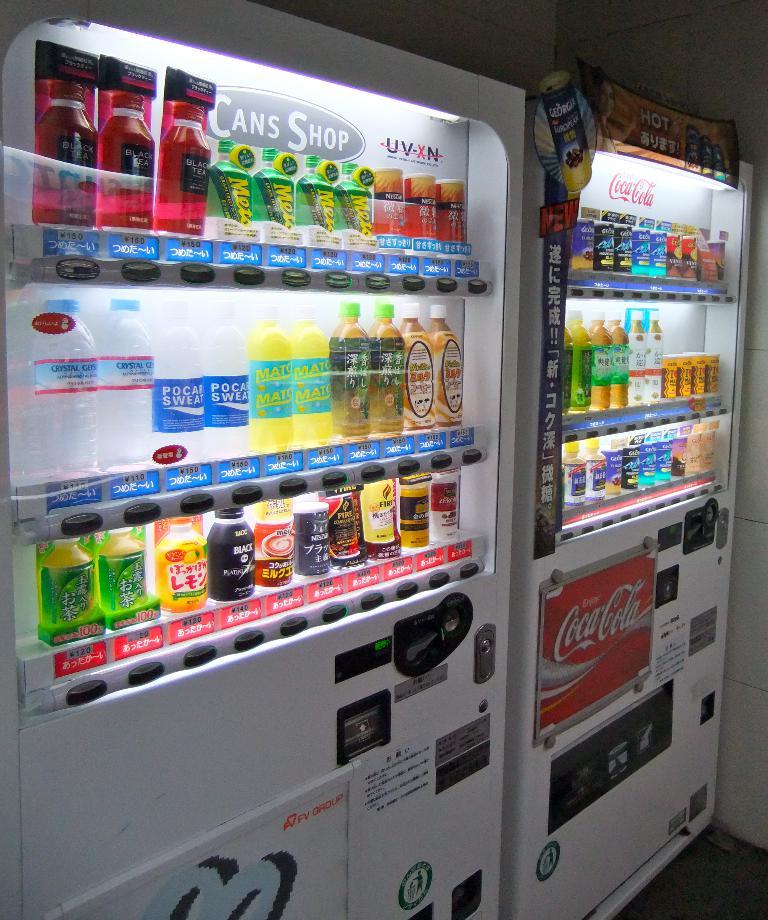What kind of shop is the machine on the left?
Provide a succinct answer. Cans. What soda is advertised on the red sign?
Make the answer very short. Coca-cola. 